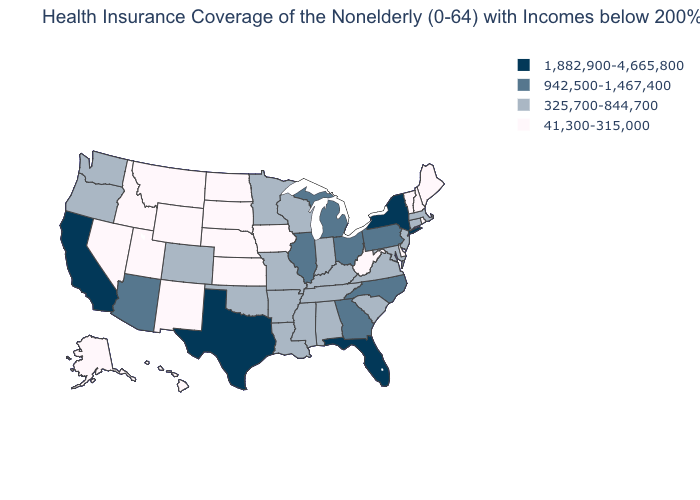Name the states that have a value in the range 1,882,900-4,665,800?
Answer briefly. California, Florida, New York, Texas. Is the legend a continuous bar?
Concise answer only. No. Name the states that have a value in the range 41,300-315,000?
Answer briefly. Alaska, Delaware, Hawaii, Idaho, Iowa, Kansas, Maine, Montana, Nebraska, Nevada, New Hampshire, New Mexico, North Dakota, Rhode Island, South Dakota, Utah, Vermont, West Virginia, Wyoming. Among the states that border Arkansas , does Louisiana have the lowest value?
Concise answer only. Yes. What is the value of Pennsylvania?
Give a very brief answer. 942,500-1,467,400. What is the lowest value in states that border Georgia?
Answer briefly. 325,700-844,700. Name the states that have a value in the range 325,700-844,700?
Quick response, please. Alabama, Arkansas, Colorado, Connecticut, Indiana, Kentucky, Louisiana, Maryland, Massachusetts, Minnesota, Mississippi, Missouri, New Jersey, Oklahoma, Oregon, South Carolina, Tennessee, Virginia, Washington, Wisconsin. What is the value of Kentucky?
Keep it brief. 325,700-844,700. What is the value of Arkansas?
Concise answer only. 325,700-844,700. Does New Hampshire have a lower value than Missouri?
Keep it brief. Yes. What is the value of Kentucky?
Concise answer only. 325,700-844,700. What is the highest value in states that border Alabama?
Give a very brief answer. 1,882,900-4,665,800. Does the first symbol in the legend represent the smallest category?
Be succinct. No. What is the highest value in the MidWest ?
Short answer required. 942,500-1,467,400. What is the value of New York?
Give a very brief answer. 1,882,900-4,665,800. 